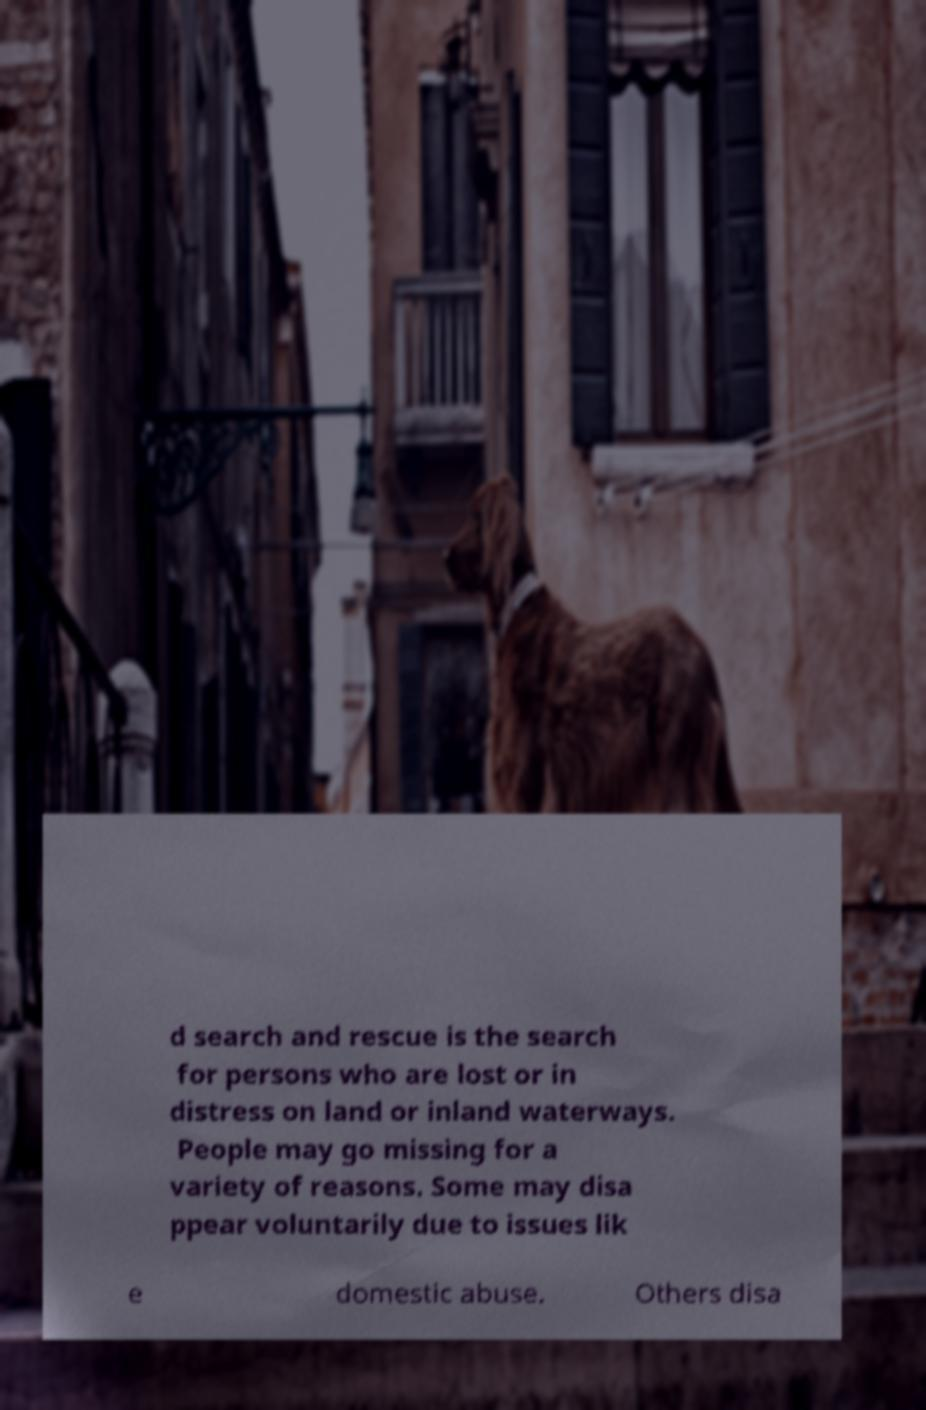Please read and relay the text visible in this image. What does it say? d search and rescue is the search for persons who are lost or in distress on land or inland waterways. People may go missing for a variety of reasons. Some may disa ppear voluntarily due to issues lik e domestic abuse. Others disa 